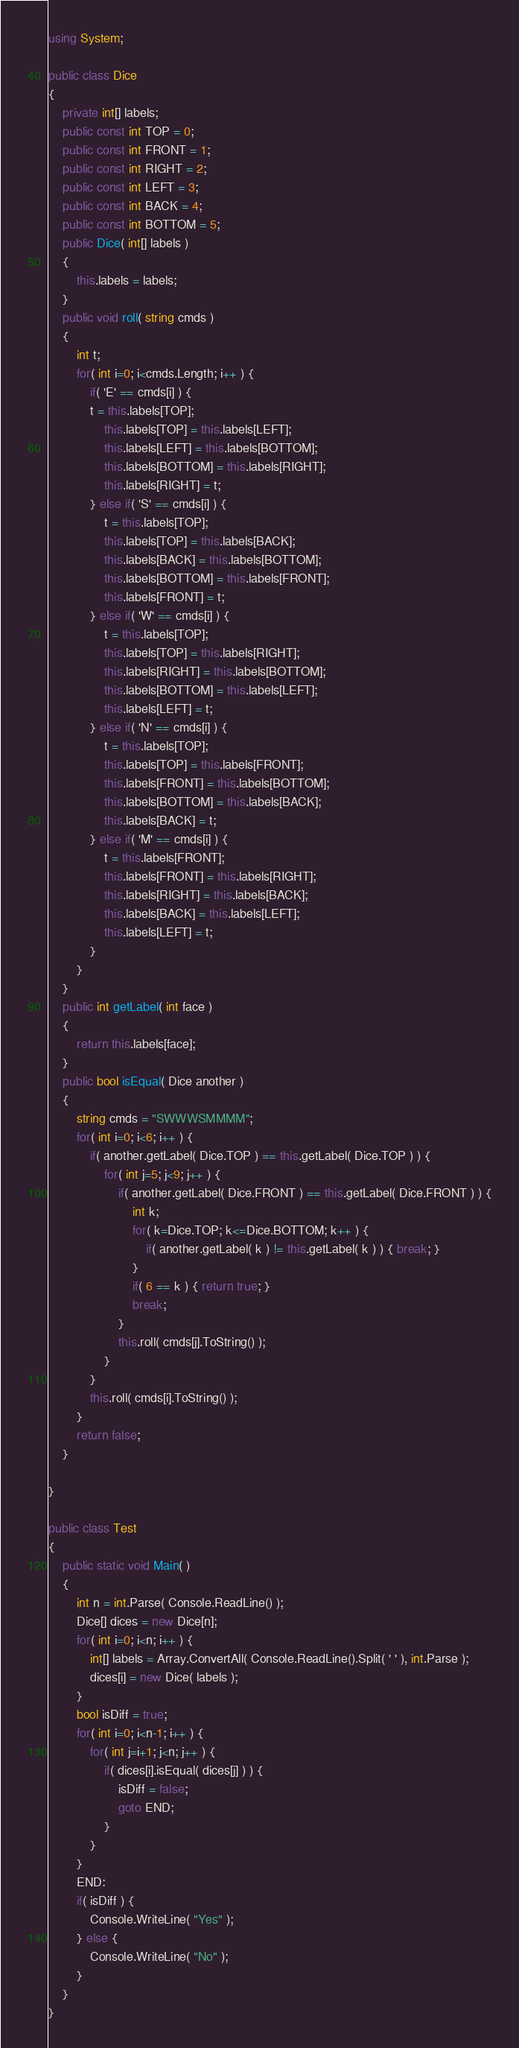<code> <loc_0><loc_0><loc_500><loc_500><_C#_>using System;

public class Dice
{
	private int[] labels;
	public const int TOP = 0;
	public const int FRONT = 1;
	public const int RIGHT = 2;
	public const int LEFT = 3;
	public const int BACK = 4;
	public const int BOTTOM = 5;
	public Dice( int[] labels )
	{
		this.labels = labels;
	}
	public void roll( string cmds )
	{
		int t;
		for( int i=0; i<cmds.Length; i++ ) {
			if( 'E' == cmds[i] ) {
			t = this.labels[TOP];
				this.labels[TOP] = this.labels[LEFT];
				this.labels[LEFT] = this.labels[BOTTOM];
				this.labels[BOTTOM] = this.labels[RIGHT];
				this.labels[RIGHT] = t;
			} else if( 'S' == cmds[i] ) {
				t = this.labels[TOP];
				this.labels[TOP] = this.labels[BACK];
				this.labels[BACK] = this.labels[BOTTOM];
				this.labels[BOTTOM] = this.labels[FRONT];
				this.labels[FRONT] = t;
			} else if( 'W' == cmds[i] ) {
				t = this.labels[TOP];
				this.labels[TOP] = this.labels[RIGHT];
				this.labels[RIGHT] = this.labels[BOTTOM];
				this.labels[BOTTOM] = this.labels[LEFT];
				this.labels[LEFT] = t;
			} else if( 'N' == cmds[i] ) {
				t = this.labels[TOP];
				this.labels[TOP] = this.labels[FRONT];
				this.labels[FRONT] = this.labels[BOTTOM];
				this.labels[BOTTOM] = this.labels[BACK];
				this.labels[BACK] = t;        
			} else if( 'M' == cmds[i] ) {
				t = this.labels[FRONT];
				this.labels[FRONT] = this.labels[RIGHT];
				this.labels[RIGHT] = this.labels[BACK];
				this.labels[BACK] = this.labels[LEFT];
				this.labels[LEFT] = t;        
			}	
		}
	}
	public int getLabel( int face )
	{
		return this.labels[face];
	}
	public bool isEqual( Dice another )
	{
		string cmds = "SWWWSMMMM";
		for( int i=0; i<6; i++ ) {
			if( another.getLabel( Dice.TOP ) == this.getLabel( Dice.TOP ) ) {
				for( int j=5; j<9; j++ ) {
					if( another.getLabel( Dice.FRONT ) == this.getLabel( Dice.FRONT ) ) {
						int k;
						for( k=Dice.TOP; k<=Dice.BOTTOM; k++ ) {
							if( another.getLabel( k ) != this.getLabel( k ) ) { break; }		
						}
						if( 6 == k ) { return true; }
						break;
					}
					this.roll( cmds[j].ToString() );		
				}
			}
			this.roll( cmds[i].ToString() );			
		}
		return false;
	}
	
}

public class Test
{
	public static void Main( )
	{
		int n = int.Parse( Console.ReadLine() );
		Dice[] dices = new Dice[n];
		for( int i=0; i<n; i++ ) {
			int[] labels = Array.ConvertAll( Console.ReadLine().Split( ' ' ), int.Parse );
			dices[i] = new Dice( labels );
		}
		bool isDiff = true;
		for( int i=0; i<n-1; i++ ) {
			for( int j=i+1; j<n; j++ ) {
				if( dices[i].isEqual( dices[j] ) ) {
					isDiff = false;
					goto END;
				}
			}
		}
		END:
		if( isDiff ) {
			Console.WriteLine( "Yes" );
		} else {		
			Console.WriteLine( "No" );		
		}
	}
}</code> 